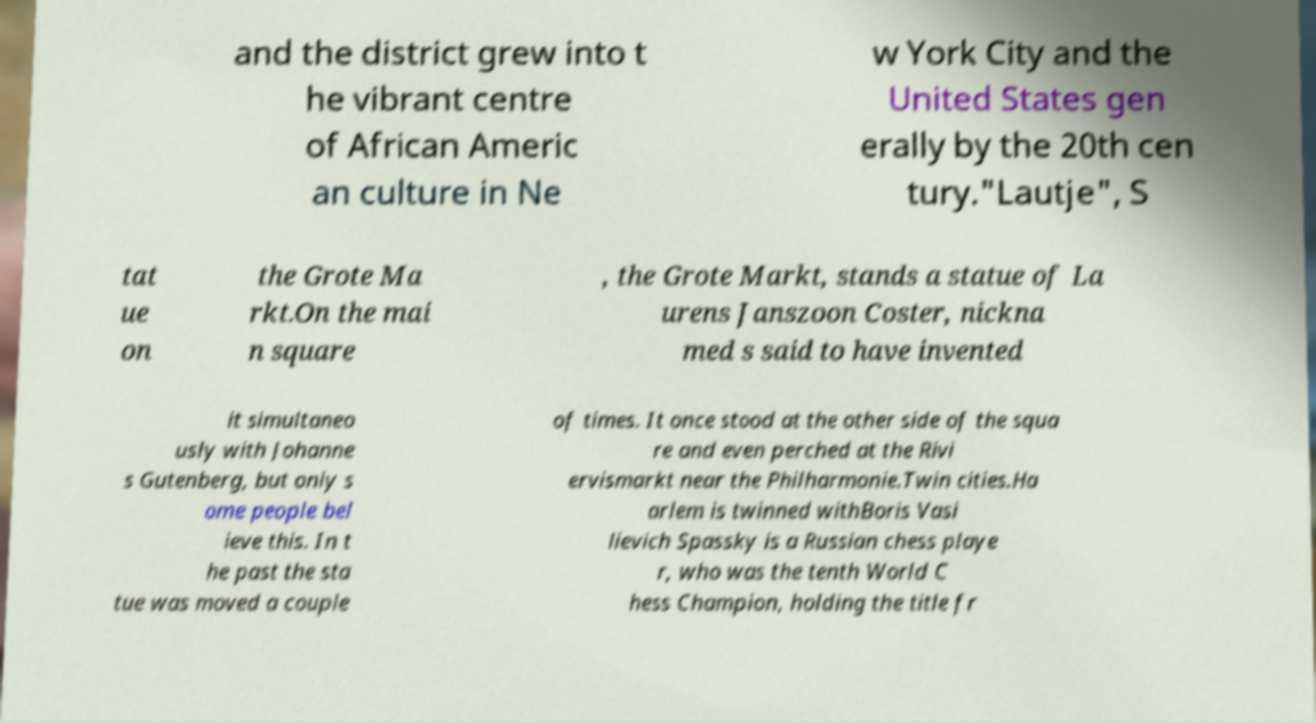What messages or text are displayed in this image? I need them in a readable, typed format. and the district grew into t he vibrant centre of African Americ an culture in Ne w York City and the United States gen erally by the 20th cen tury."Lautje", S tat ue on the Grote Ma rkt.On the mai n square , the Grote Markt, stands a statue of La urens Janszoon Coster, nickna med s said to have invented it simultaneo usly with Johanne s Gutenberg, but only s ome people bel ieve this. In t he past the sta tue was moved a couple of times. It once stood at the other side of the squa re and even perched at the Rivi ervismarkt near the Philharmonie.Twin cities.Ha arlem is twinned withBoris Vasi lievich Spassky is a Russian chess playe r, who was the tenth World C hess Champion, holding the title fr 